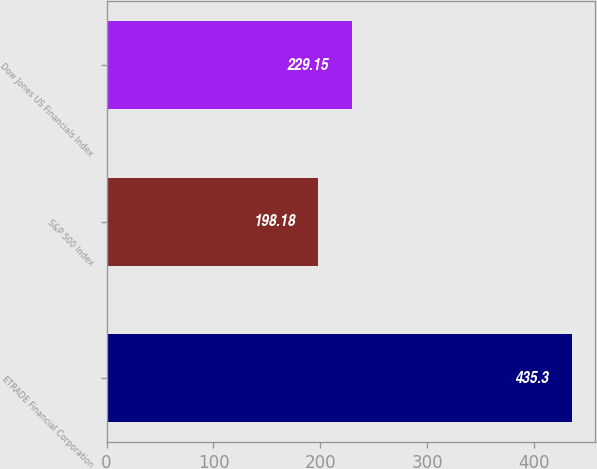Convert chart. <chart><loc_0><loc_0><loc_500><loc_500><bar_chart><fcel>ETRADE Financial Corporation<fcel>S&P 500 Index<fcel>Dow Jones US Financials Index<nl><fcel>435.3<fcel>198.18<fcel>229.15<nl></chart> 